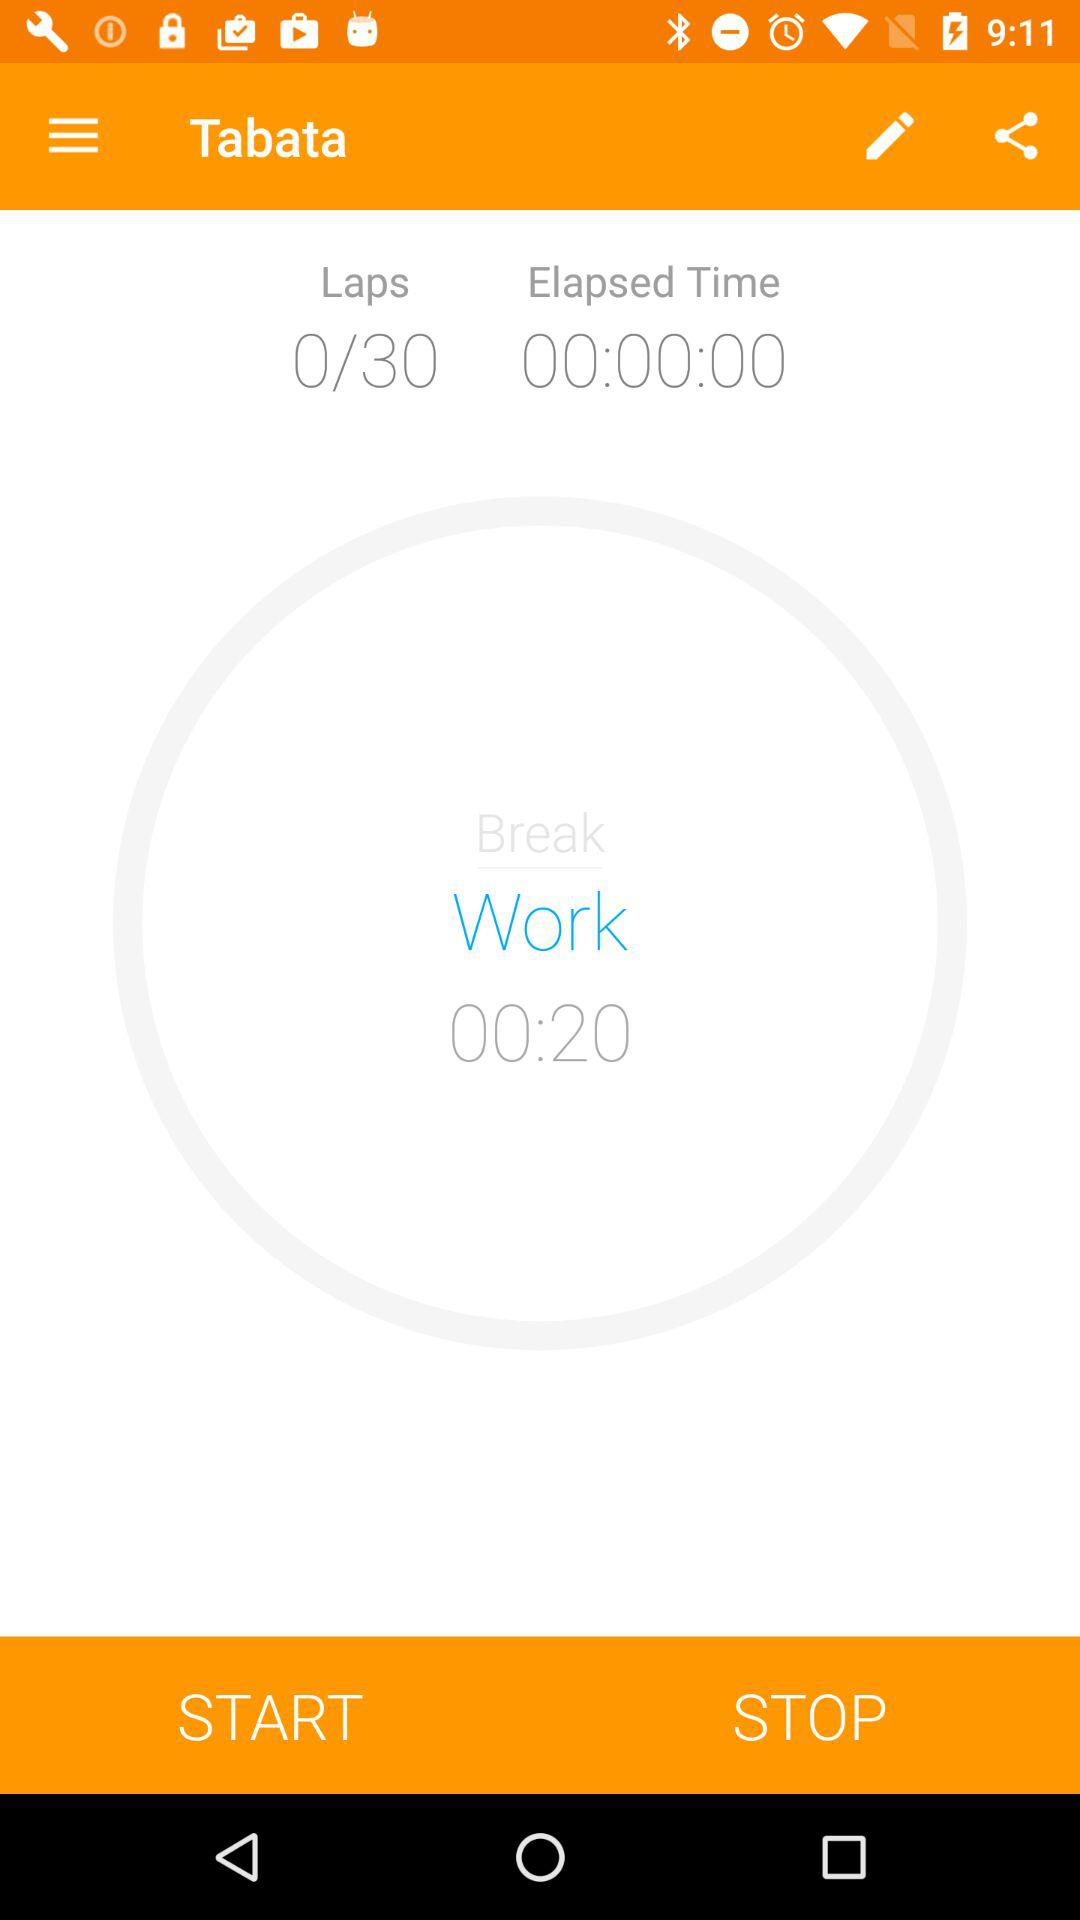What is the name of the application? The name of the application is "Tabata". 